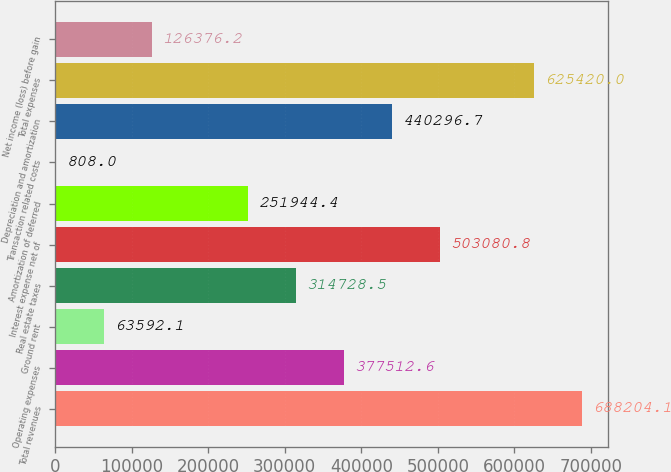Convert chart to OTSL. <chart><loc_0><loc_0><loc_500><loc_500><bar_chart><fcel>Total revenues<fcel>Operating expenses<fcel>Ground rent<fcel>Real estate taxes<fcel>Interest expense net of<fcel>Amortization of deferred<fcel>Transaction related costs<fcel>Depreciation and amortization<fcel>Total expenses<fcel>Net income (loss) before gain<nl><fcel>688204<fcel>377513<fcel>63592.1<fcel>314728<fcel>503081<fcel>251944<fcel>808<fcel>440297<fcel>625420<fcel>126376<nl></chart> 